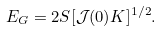<formula> <loc_0><loc_0><loc_500><loc_500>E _ { G } = 2 S [ \mathcal { J } ( 0 ) K ] ^ { 1 / 2 } .</formula> 